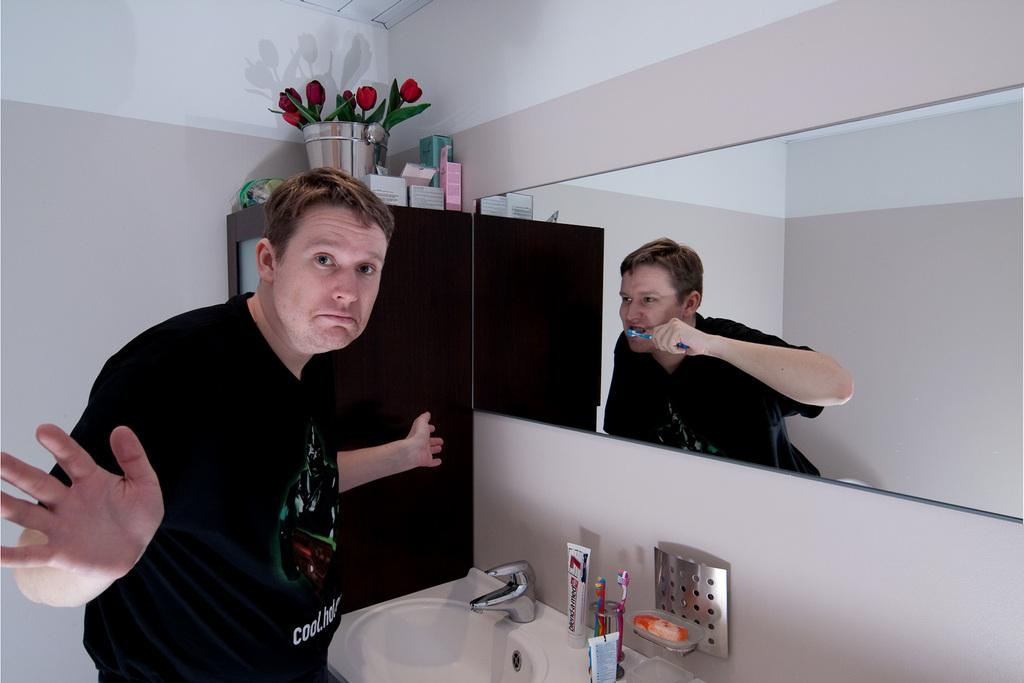<image>
Provide a brief description of the given image. A man standing in front of a mirror with a tube of defend-a-med in front of him on the counter. 